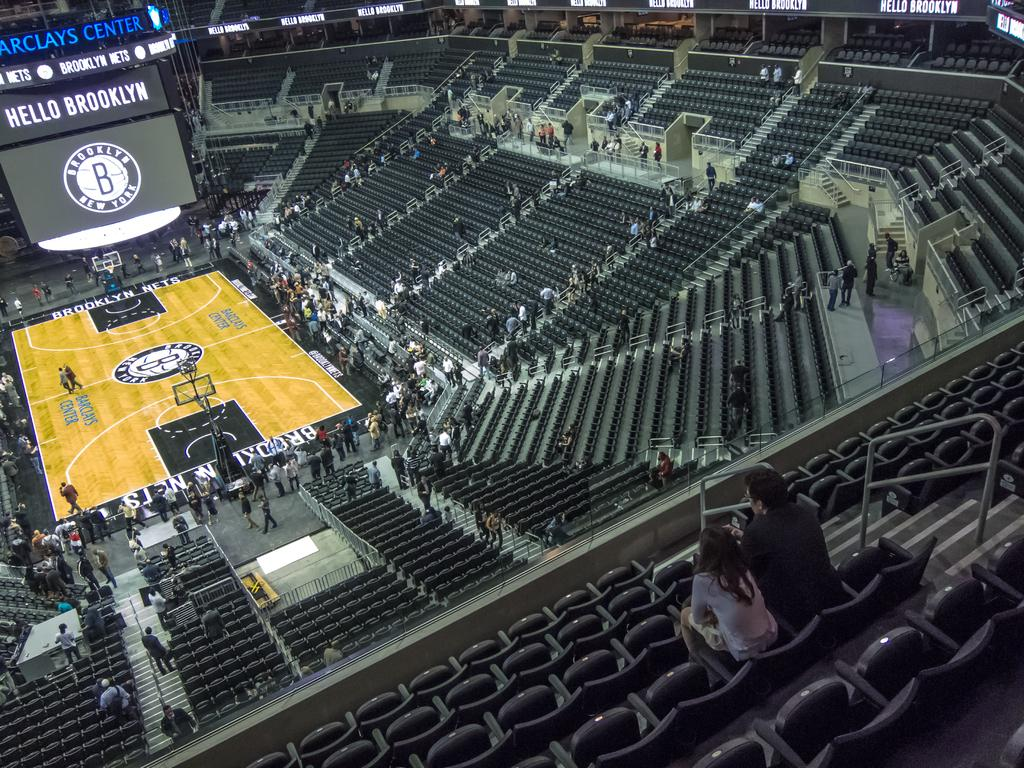<image>
Create a compact narrative representing the image presented. a Brooklyn Nets scoreboard above the court of the Nets 